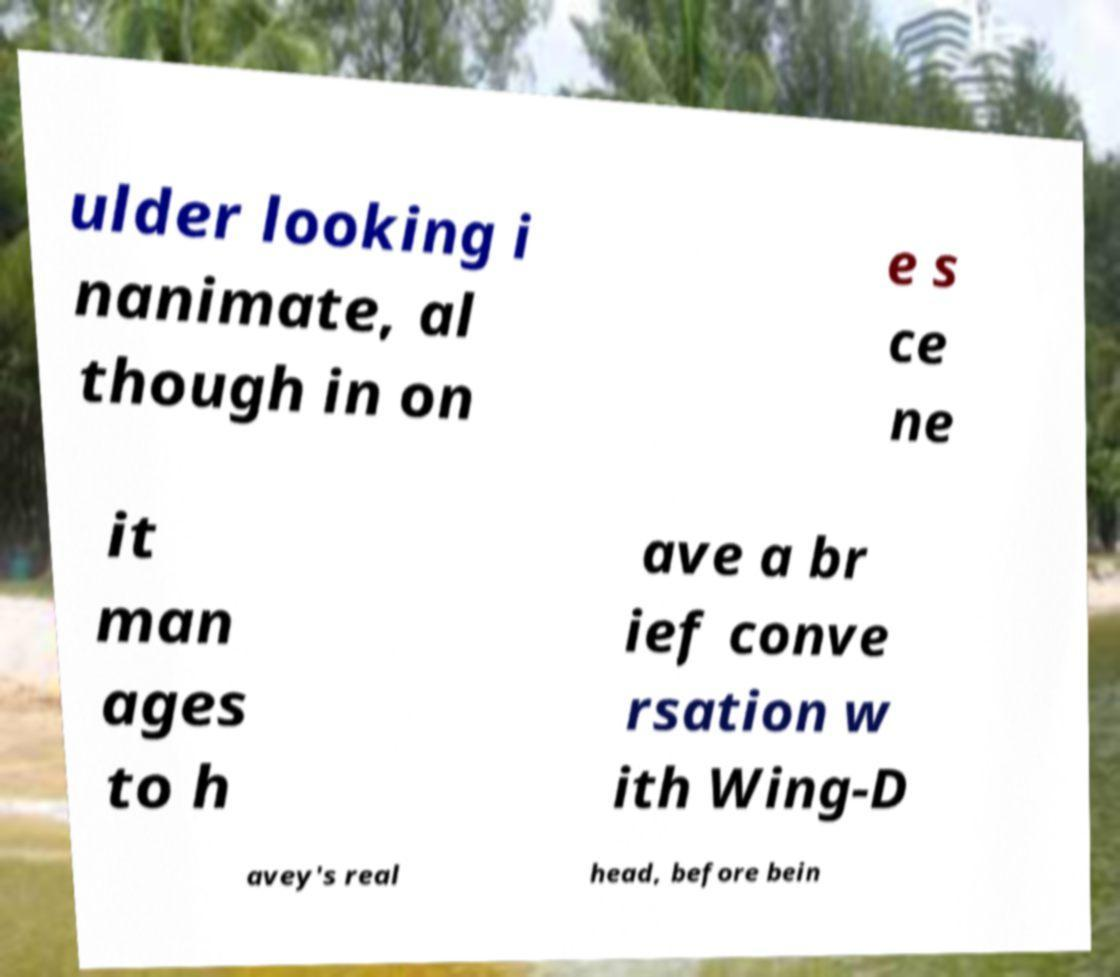Please read and relay the text visible in this image. What does it say? ulder looking i nanimate, al though in on e s ce ne it man ages to h ave a br ief conve rsation w ith Wing-D avey's real head, before bein 